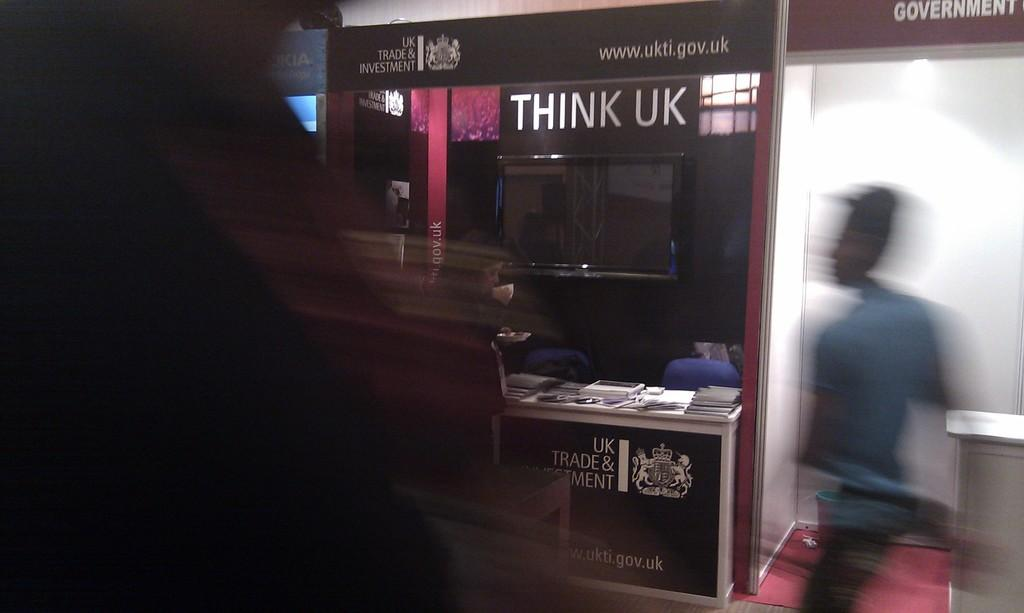<image>
Create a compact narrative representing the image presented. A man walks past a display for Think UK. 